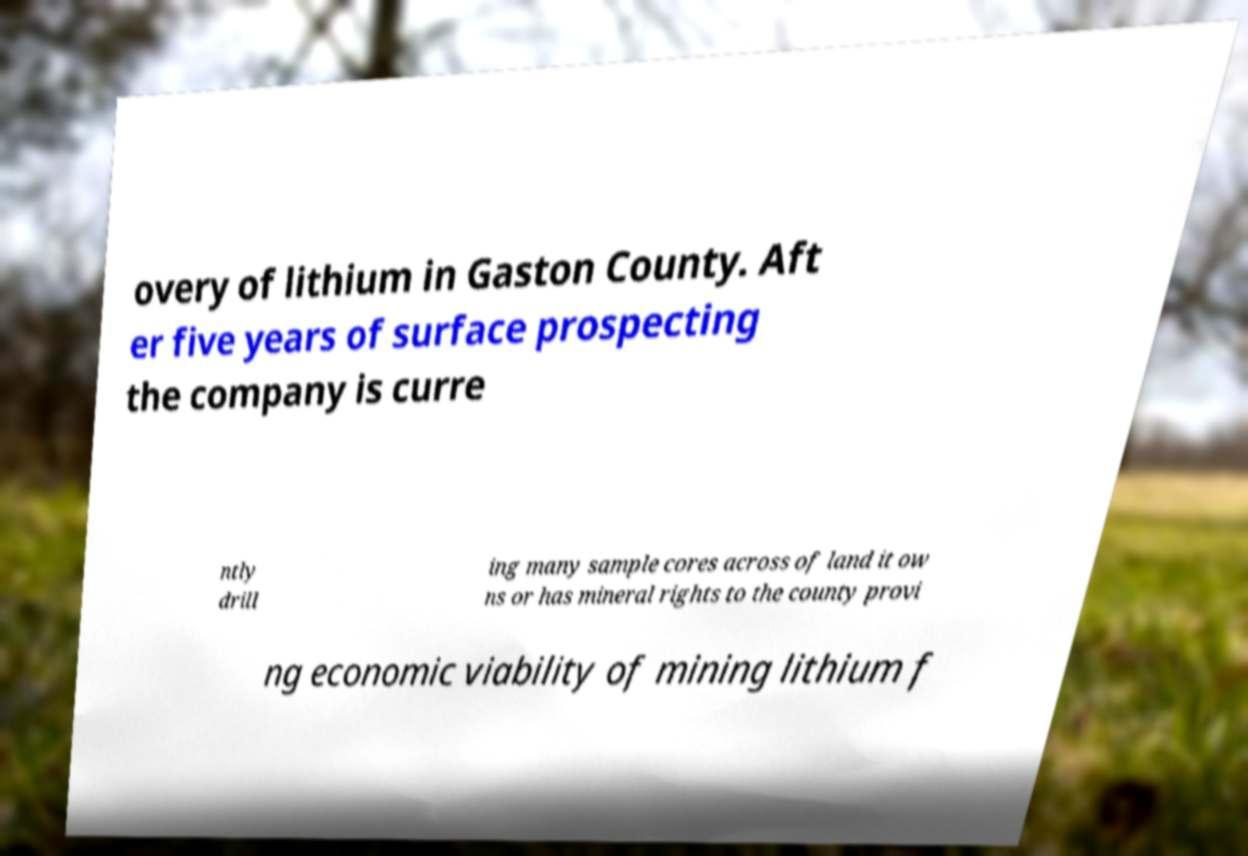What messages or text are displayed in this image? I need them in a readable, typed format. overy of lithium in Gaston County. Aft er five years of surface prospecting the company is curre ntly drill ing many sample cores across of land it ow ns or has mineral rights to the county provi ng economic viability of mining lithium f 